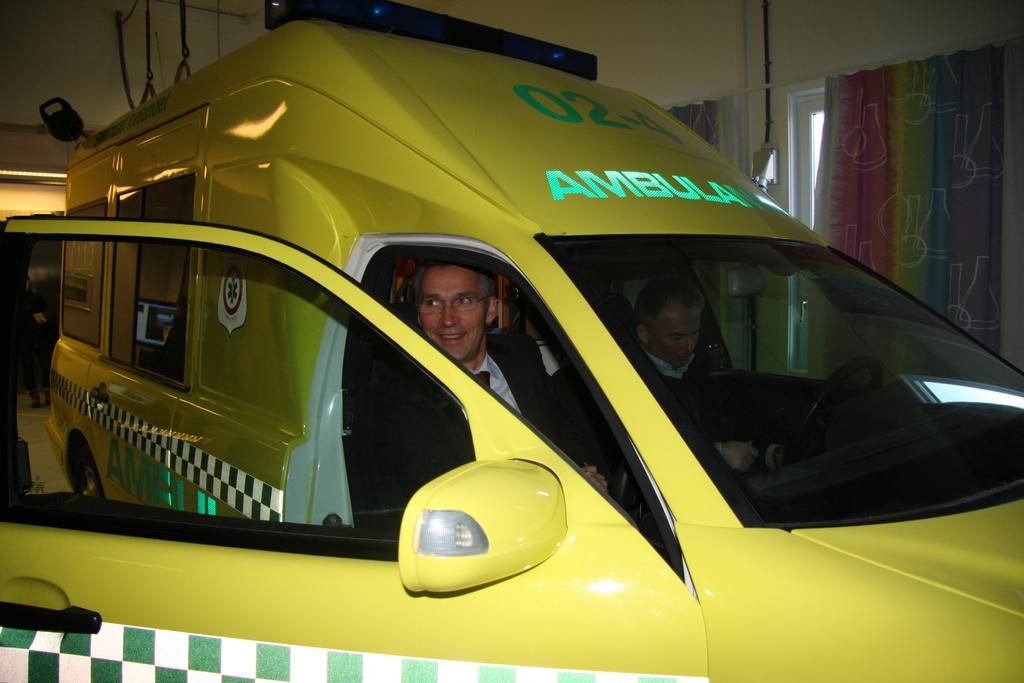<image>
Create a compact narrative representing the image presented. A man in a yellow ambulance is smiling out of an open door. 